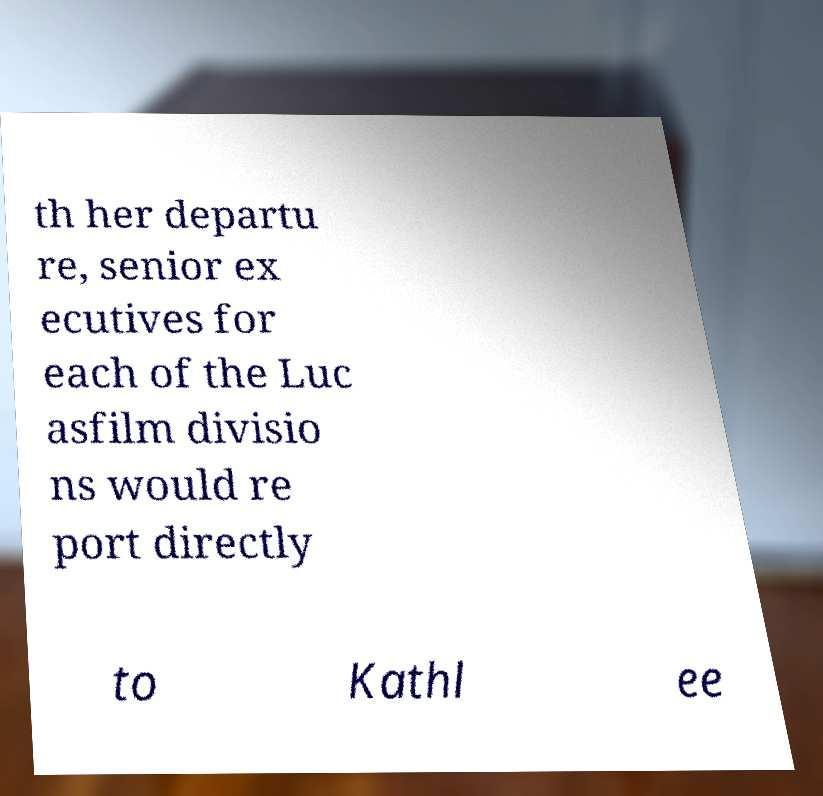Could you assist in decoding the text presented in this image and type it out clearly? th her departu re, senior ex ecutives for each of the Luc asfilm divisio ns would re port directly to Kathl ee 